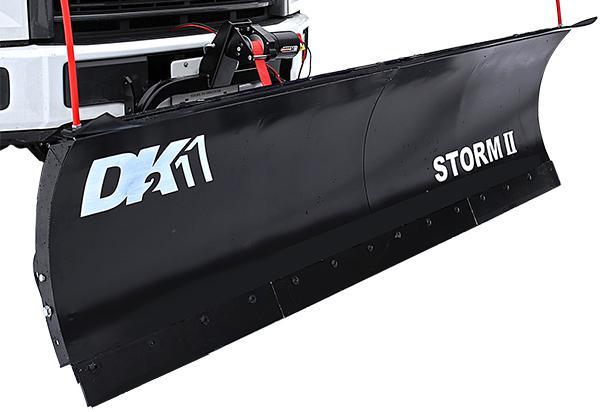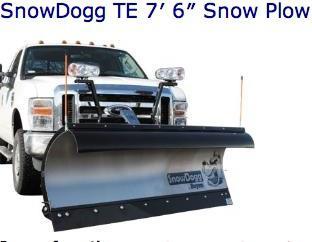The first image is the image on the left, the second image is the image on the right. Examine the images to the left and right. Is the description "One image shows a complete angled side view of a pickup truck with a front snow blade, while a second image shows an unattached orange snow blade." accurate? Answer yes or no. No. The first image is the image on the left, the second image is the image on the right. For the images shown, is this caption "One image shows an orange plow that is not attached to a vehicle." true? Answer yes or no. No. 